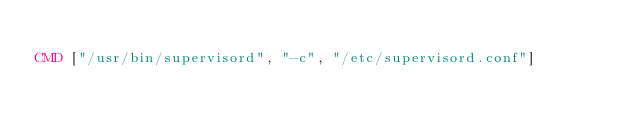<code> <loc_0><loc_0><loc_500><loc_500><_Dockerfile_>
CMD ["/usr/bin/supervisord", "-c", "/etc/supervisord.conf"]
</code> 